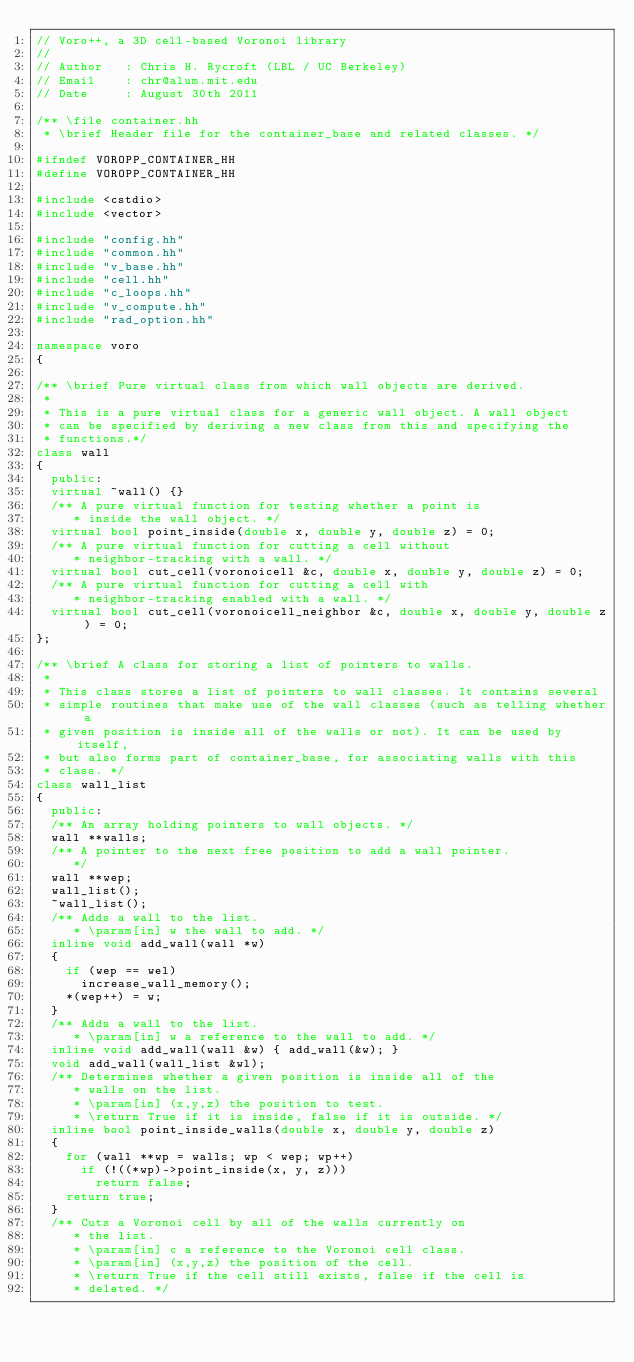<code> <loc_0><loc_0><loc_500><loc_500><_C++_>// Voro++, a 3D cell-based Voronoi library
//
// Author   : Chris H. Rycroft (LBL / UC Berkeley)
// Email    : chr@alum.mit.edu
// Date     : August 30th 2011

/** \file container.hh
 * \brief Header file for the container_base and related classes. */

#ifndef VOROPP_CONTAINER_HH
#define VOROPP_CONTAINER_HH

#include <cstdio>
#include <vector>

#include "config.hh"
#include "common.hh"
#include "v_base.hh"
#include "cell.hh"
#include "c_loops.hh"
#include "v_compute.hh"
#include "rad_option.hh"

namespace voro
{

/** \brief Pure virtual class from which wall objects are derived.
 *
 * This is a pure virtual class for a generic wall object. A wall object
 * can be specified by deriving a new class from this and specifying the
 * functions.*/
class wall
{
  public:
	virtual ~wall() {}
	/** A pure virtual function for testing whether a point is
		 * inside the wall object. */
	virtual bool point_inside(double x, double y, double z) = 0;
	/** A pure virtual function for cutting a cell without
		 * neighbor-tracking with a wall. */
	virtual bool cut_cell(voronoicell &c, double x, double y, double z) = 0;
	/** A pure virtual function for cutting a cell with
		 * neighbor-tracking enabled with a wall. */
	virtual bool cut_cell(voronoicell_neighbor &c, double x, double y, double z) = 0;
};

/** \brief A class for storing a list of pointers to walls.
 *
 * This class stores a list of pointers to wall classes. It contains several
 * simple routines that make use of the wall classes (such as telling whether a
 * given position is inside all of the walls or not). It can be used by itself,
 * but also forms part of container_base, for associating walls with this
 * class. */
class wall_list
{
  public:
	/** An array holding pointers to wall objects. */
	wall **walls;
	/** A pointer to the next free position to add a wall pointer.
		 */
	wall **wep;
	wall_list();
	~wall_list();
	/** Adds a wall to the list.
		 * \param[in] w the wall to add. */
	inline void add_wall(wall *w)
	{
		if (wep == wel)
			increase_wall_memory();
		*(wep++) = w;
	}
	/** Adds a wall to the list.
		 * \param[in] w a reference to the wall to add. */
	inline void add_wall(wall &w) { add_wall(&w); }
	void add_wall(wall_list &wl);
	/** Determines whether a given position is inside all of the
		 * walls on the list.
		 * \param[in] (x,y,z) the position to test.
		 * \return True if it is inside, false if it is outside. */
	inline bool point_inside_walls(double x, double y, double z)
	{
		for (wall **wp = walls; wp < wep; wp++)
			if (!((*wp)->point_inside(x, y, z)))
				return false;
		return true;
	}
	/** Cuts a Voronoi cell by all of the walls currently on
		 * the list.
		 * \param[in] c a reference to the Voronoi cell class.
		 * \param[in] (x,y,z) the position of the cell.
		 * \return True if the cell still exists, false if the cell is
		 * deleted. */</code> 